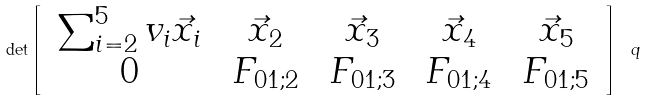<formula> <loc_0><loc_0><loc_500><loc_500>\det \left [ \begin{array} { c c c c c } \, \sum _ { i = 2 } ^ { 5 } v _ { i } \vec { x } _ { i } \, & \, \vec { x } _ { 2 } \, & \, \vec { x } _ { 3 } \, & \, \vec { x } _ { 4 } \, & \, \vec { x } _ { 5 } \, \\ \, 0 \, & \, F _ { 0 1 ; 2 } \, & \, F _ { 0 1 ; 3 } \, & \, F _ { 0 1 ; 4 } \, & \, F _ { 0 1 ; 5 } \, \end{array} \right ] \ q</formula> 